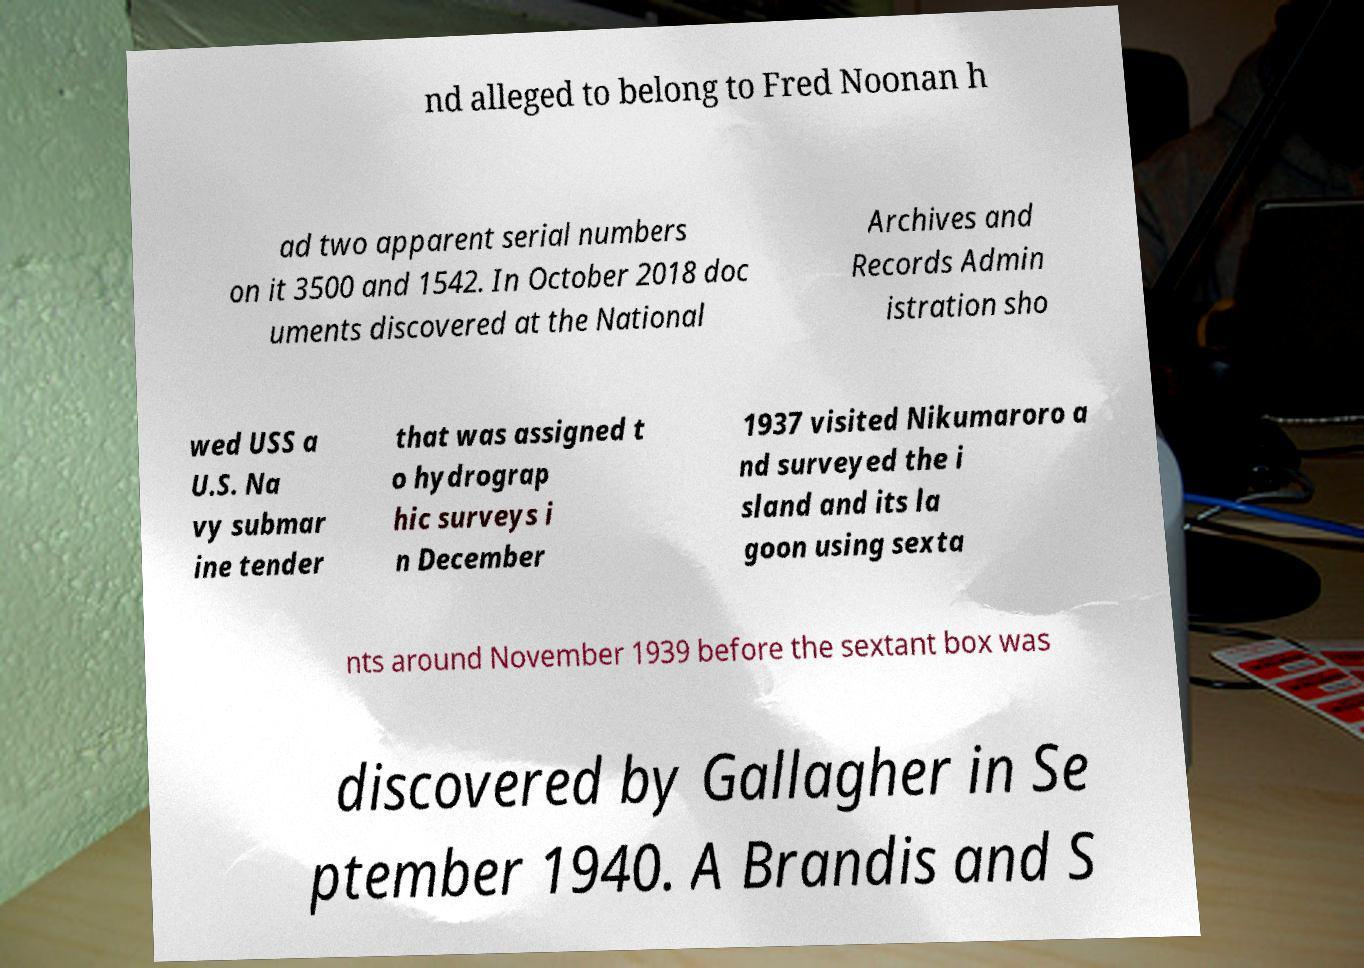For documentation purposes, I need the text within this image transcribed. Could you provide that? nd alleged to belong to Fred Noonan h ad two apparent serial numbers on it 3500 and 1542. In October 2018 doc uments discovered at the National Archives and Records Admin istration sho wed USS a U.S. Na vy submar ine tender that was assigned t o hydrograp hic surveys i n December 1937 visited Nikumaroro a nd surveyed the i sland and its la goon using sexta nts around November 1939 before the sextant box was discovered by Gallagher in Se ptember 1940. A Brandis and S 